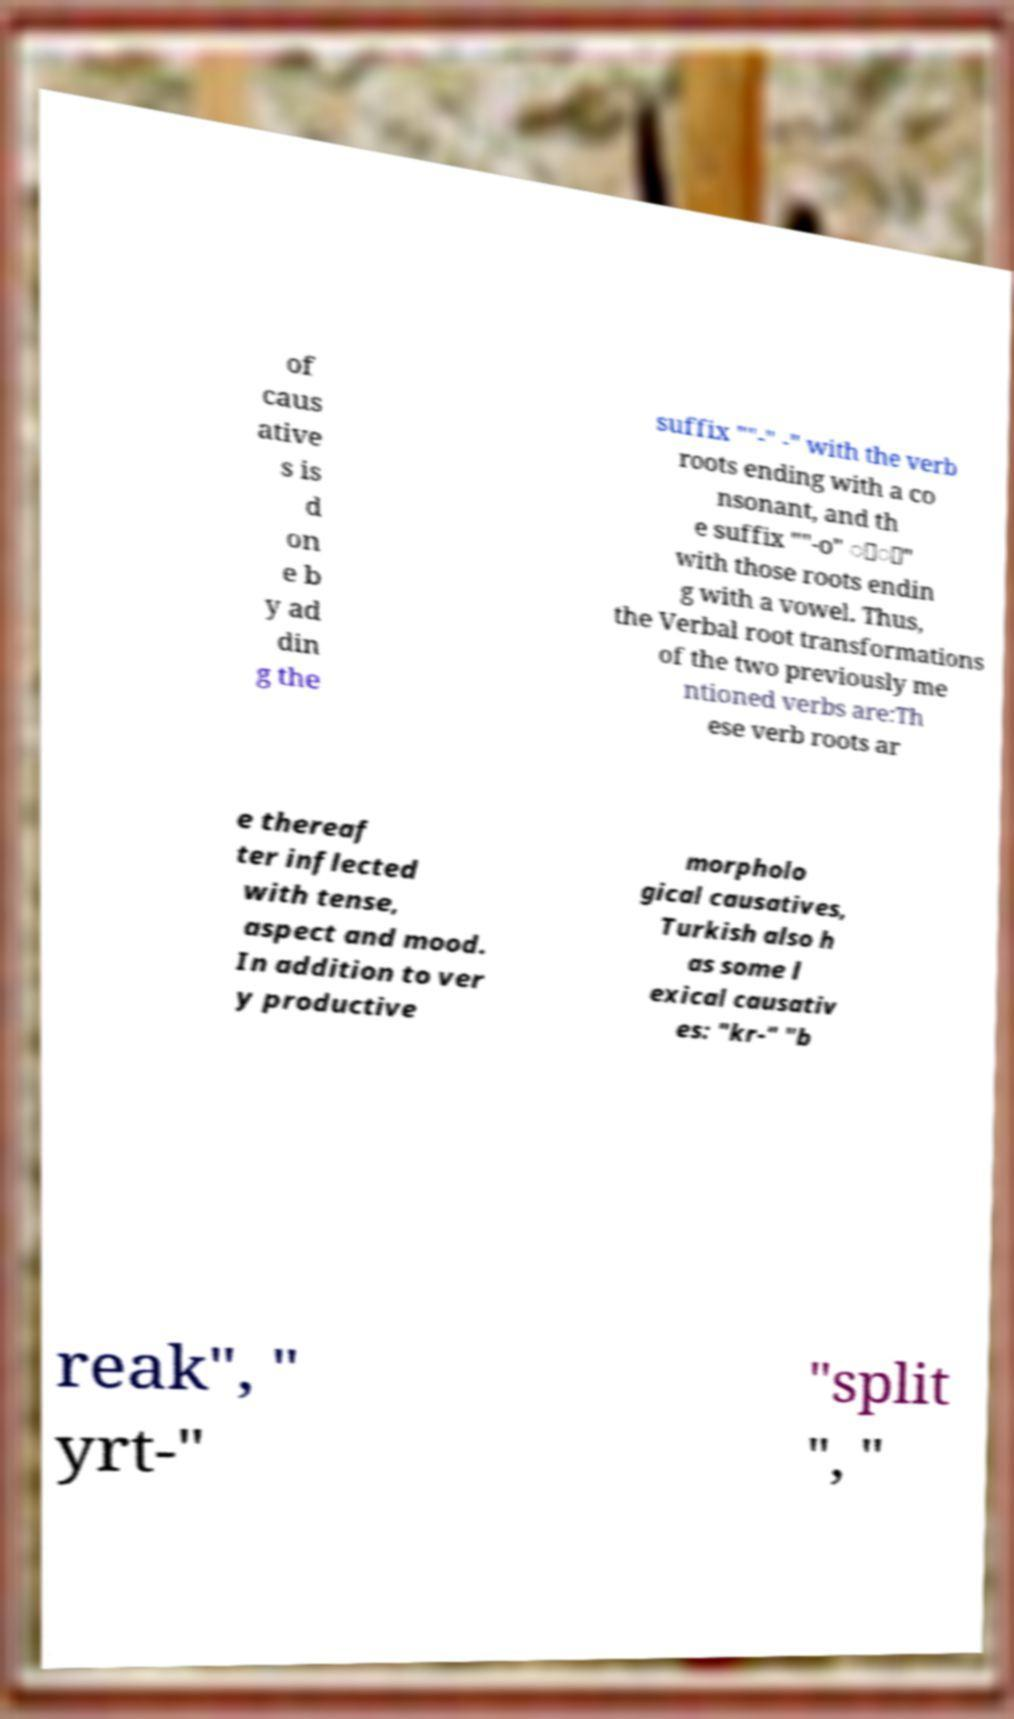I need the written content from this picture converted into text. Can you do that? of caus ative s is d on e b y ad din g the suffix ""-" -" with the verb roots ending with a co nsonant, and th e suffix ""-o" ়া" with those roots endin g with a vowel. Thus, the Verbal root transformations of the two previously me ntioned verbs are:Th ese verb roots ar e thereaf ter inflected with tense, aspect and mood. In addition to ver y productive morpholo gical causatives, Turkish also h as some l exical causativ es: "kr-" "b reak", " yrt-" "split ", " 